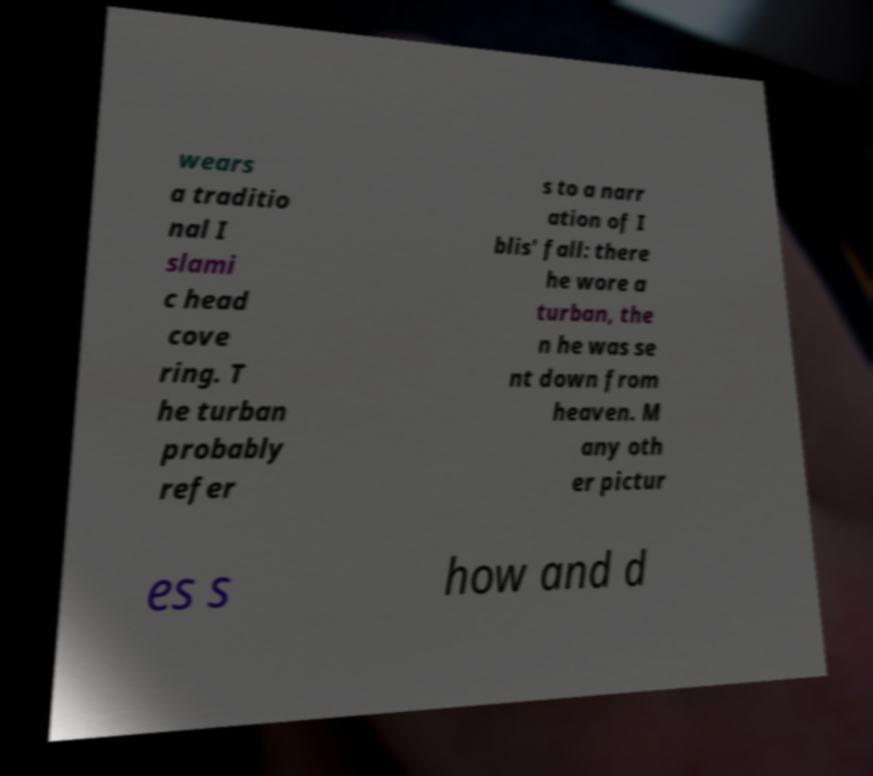Could you assist in decoding the text presented in this image and type it out clearly? wears a traditio nal I slami c head cove ring. T he turban probably refer s to a narr ation of I blis' fall: there he wore a turban, the n he was se nt down from heaven. M any oth er pictur es s how and d 